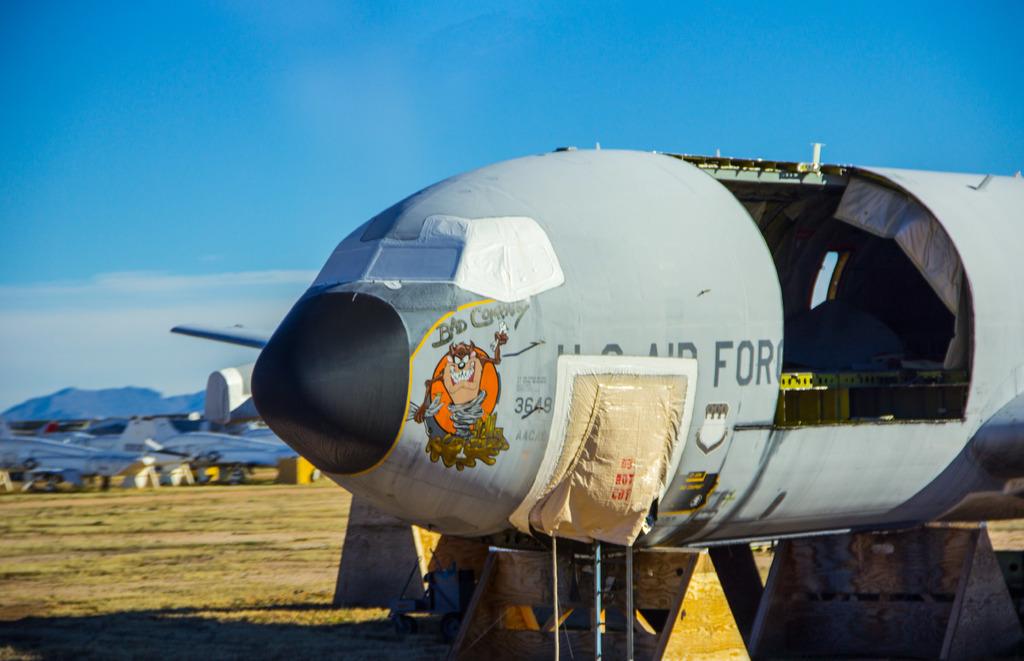How is the tasmanian devil described as?
Provide a succinct answer. Bad company. 